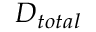Convert formula to latex. <formula><loc_0><loc_0><loc_500><loc_500>D _ { t o t a l }</formula> 